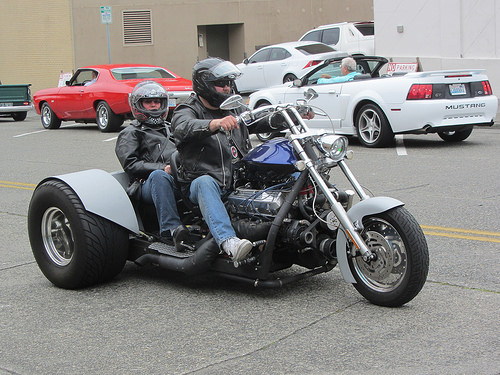<image>
Is there a human on the bike? Yes. Looking at the image, I can see the human is positioned on top of the bike, with the bike providing support. Is there a bike in front of the car? Yes. The bike is positioned in front of the car, appearing closer to the camera viewpoint. 